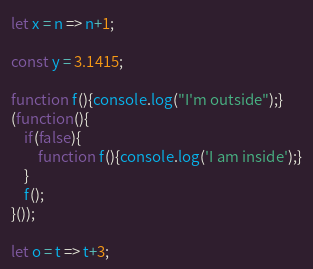<code> <loc_0><loc_0><loc_500><loc_500><_JavaScript_>
let x = n => n+1;

const y = 3.1415;

function f(){console.log("I'm outside");}
(function(){
	if(false){
		function f(){console.log('I am inside');}
	}
	f();
}());

let o = t => t+3;</code> 